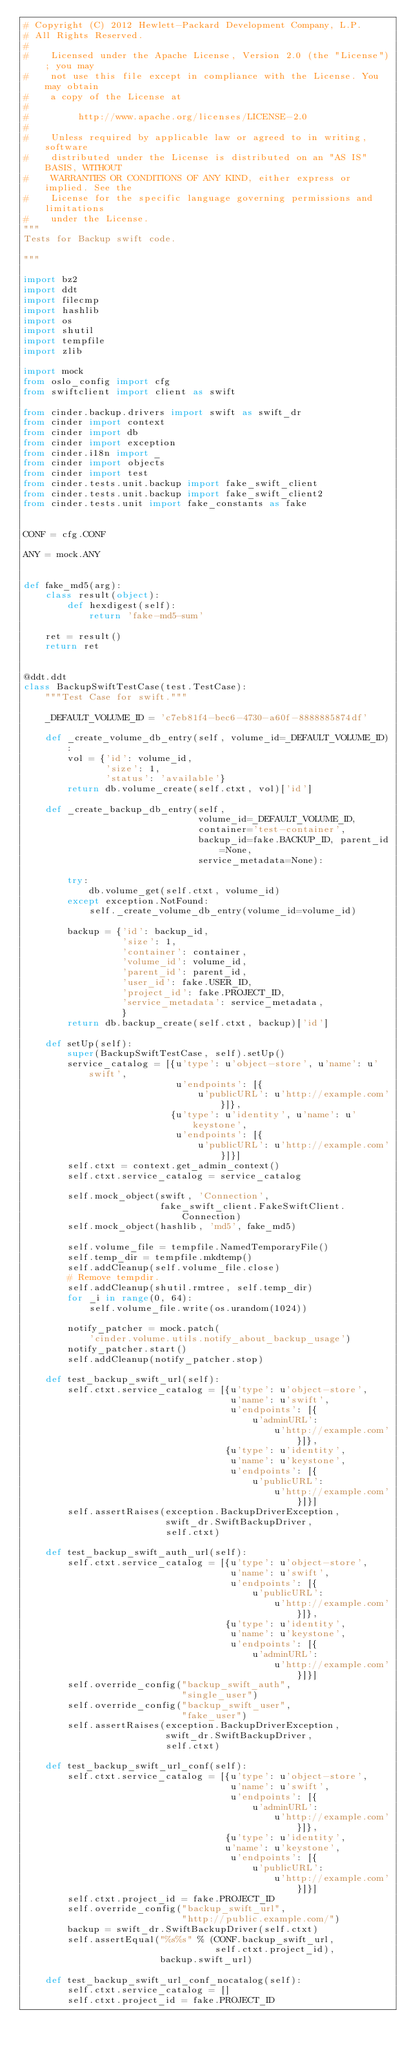Convert code to text. <code><loc_0><loc_0><loc_500><loc_500><_Python_># Copyright (C) 2012 Hewlett-Packard Development Company, L.P.
# All Rights Reserved.
#
#    Licensed under the Apache License, Version 2.0 (the "License"); you may
#    not use this file except in compliance with the License. You may obtain
#    a copy of the License at
#
#         http://www.apache.org/licenses/LICENSE-2.0
#
#    Unless required by applicable law or agreed to in writing, software
#    distributed under the License is distributed on an "AS IS" BASIS, WITHOUT
#    WARRANTIES OR CONDITIONS OF ANY KIND, either express or implied. See the
#    License for the specific language governing permissions and limitations
#    under the License.
"""
Tests for Backup swift code.

"""

import bz2
import ddt
import filecmp
import hashlib
import os
import shutil
import tempfile
import zlib

import mock
from oslo_config import cfg
from swiftclient import client as swift

from cinder.backup.drivers import swift as swift_dr
from cinder import context
from cinder import db
from cinder import exception
from cinder.i18n import _
from cinder import objects
from cinder import test
from cinder.tests.unit.backup import fake_swift_client
from cinder.tests.unit.backup import fake_swift_client2
from cinder.tests.unit import fake_constants as fake


CONF = cfg.CONF

ANY = mock.ANY


def fake_md5(arg):
    class result(object):
        def hexdigest(self):
            return 'fake-md5-sum'

    ret = result()
    return ret


@ddt.ddt
class BackupSwiftTestCase(test.TestCase):
    """Test Case for swift."""

    _DEFAULT_VOLUME_ID = 'c7eb81f4-bec6-4730-a60f-8888885874df'

    def _create_volume_db_entry(self, volume_id=_DEFAULT_VOLUME_ID):
        vol = {'id': volume_id,
               'size': 1,
               'status': 'available'}
        return db.volume_create(self.ctxt, vol)['id']

    def _create_backup_db_entry(self,
                                volume_id=_DEFAULT_VOLUME_ID,
                                container='test-container',
                                backup_id=fake.BACKUP_ID, parent_id=None,
                                service_metadata=None):

        try:
            db.volume_get(self.ctxt, volume_id)
        except exception.NotFound:
            self._create_volume_db_entry(volume_id=volume_id)

        backup = {'id': backup_id,
                  'size': 1,
                  'container': container,
                  'volume_id': volume_id,
                  'parent_id': parent_id,
                  'user_id': fake.USER_ID,
                  'project_id': fake.PROJECT_ID,
                  'service_metadata': service_metadata,
                  }
        return db.backup_create(self.ctxt, backup)['id']

    def setUp(self):
        super(BackupSwiftTestCase, self).setUp()
        service_catalog = [{u'type': u'object-store', u'name': u'swift',
                            u'endpoints': [{
                                u'publicURL': u'http://example.com'}]},
                           {u'type': u'identity', u'name': u'keystone',
                            u'endpoints': [{
                                u'publicURL': u'http://example.com'}]}]
        self.ctxt = context.get_admin_context()
        self.ctxt.service_catalog = service_catalog

        self.mock_object(swift, 'Connection',
                         fake_swift_client.FakeSwiftClient.Connection)
        self.mock_object(hashlib, 'md5', fake_md5)

        self.volume_file = tempfile.NamedTemporaryFile()
        self.temp_dir = tempfile.mkdtemp()
        self.addCleanup(self.volume_file.close)
        # Remove tempdir.
        self.addCleanup(shutil.rmtree, self.temp_dir)
        for _i in range(0, 64):
            self.volume_file.write(os.urandom(1024))

        notify_patcher = mock.patch(
            'cinder.volume.utils.notify_about_backup_usage')
        notify_patcher.start()
        self.addCleanup(notify_patcher.stop)

    def test_backup_swift_url(self):
        self.ctxt.service_catalog = [{u'type': u'object-store',
                                      u'name': u'swift',
                                      u'endpoints': [{
                                          u'adminURL':
                                              u'http://example.com'}]},
                                     {u'type': u'identity',
                                      u'name': u'keystone',
                                      u'endpoints': [{
                                          u'publicURL':
                                              u'http://example.com'}]}]
        self.assertRaises(exception.BackupDriverException,
                          swift_dr.SwiftBackupDriver,
                          self.ctxt)

    def test_backup_swift_auth_url(self):
        self.ctxt.service_catalog = [{u'type': u'object-store',
                                      u'name': u'swift',
                                      u'endpoints': [{
                                          u'publicURL':
                                              u'http://example.com'}]},
                                     {u'type': u'identity',
                                      u'name': u'keystone',
                                      u'endpoints': [{
                                          u'adminURL':
                                              u'http://example.com'}]}]
        self.override_config("backup_swift_auth",
                             "single_user")
        self.override_config("backup_swift_user",
                             "fake_user")
        self.assertRaises(exception.BackupDriverException,
                          swift_dr.SwiftBackupDriver,
                          self.ctxt)

    def test_backup_swift_url_conf(self):
        self.ctxt.service_catalog = [{u'type': u'object-store',
                                      u'name': u'swift',
                                      u'endpoints': [{
                                          u'adminURL':
                                              u'http://example.com'}]},
                                     {u'type': u'identity',
                                     u'name': u'keystone',
                                      u'endpoints': [{
                                          u'publicURL':
                                              u'http://example.com'}]}]
        self.ctxt.project_id = fake.PROJECT_ID
        self.override_config("backup_swift_url",
                             "http://public.example.com/")
        backup = swift_dr.SwiftBackupDriver(self.ctxt)
        self.assertEqual("%s%s" % (CONF.backup_swift_url,
                                   self.ctxt.project_id),
                         backup.swift_url)

    def test_backup_swift_url_conf_nocatalog(self):
        self.ctxt.service_catalog = []
        self.ctxt.project_id = fake.PROJECT_ID</code> 